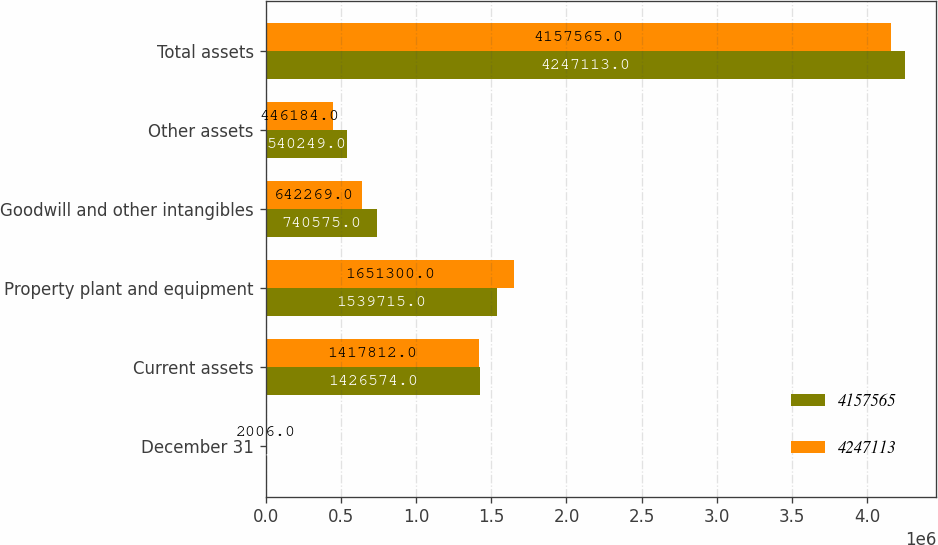<chart> <loc_0><loc_0><loc_500><loc_500><stacked_bar_chart><ecel><fcel>December 31<fcel>Current assets<fcel>Property plant and equipment<fcel>Goodwill and other intangibles<fcel>Other assets<fcel>Total assets<nl><fcel>4.15756e+06<fcel>2007<fcel>1.42657e+06<fcel>1.53972e+06<fcel>740575<fcel>540249<fcel>4.24711e+06<nl><fcel>4.24711e+06<fcel>2006<fcel>1.41781e+06<fcel>1.6513e+06<fcel>642269<fcel>446184<fcel>4.15756e+06<nl></chart> 